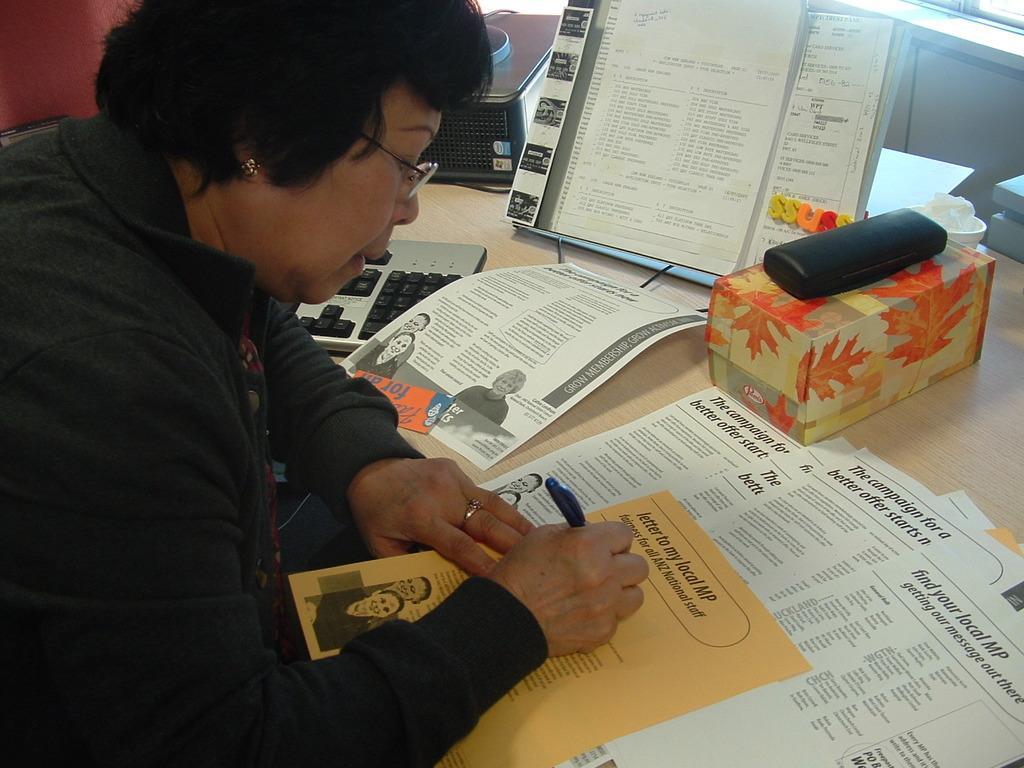Can you describe this image briefly? In this image we can see a woman. In front of the women, we can see a table. On the table, we can see papers, box, keyboard and so many objects. It seems like a window in the right top of the image. 